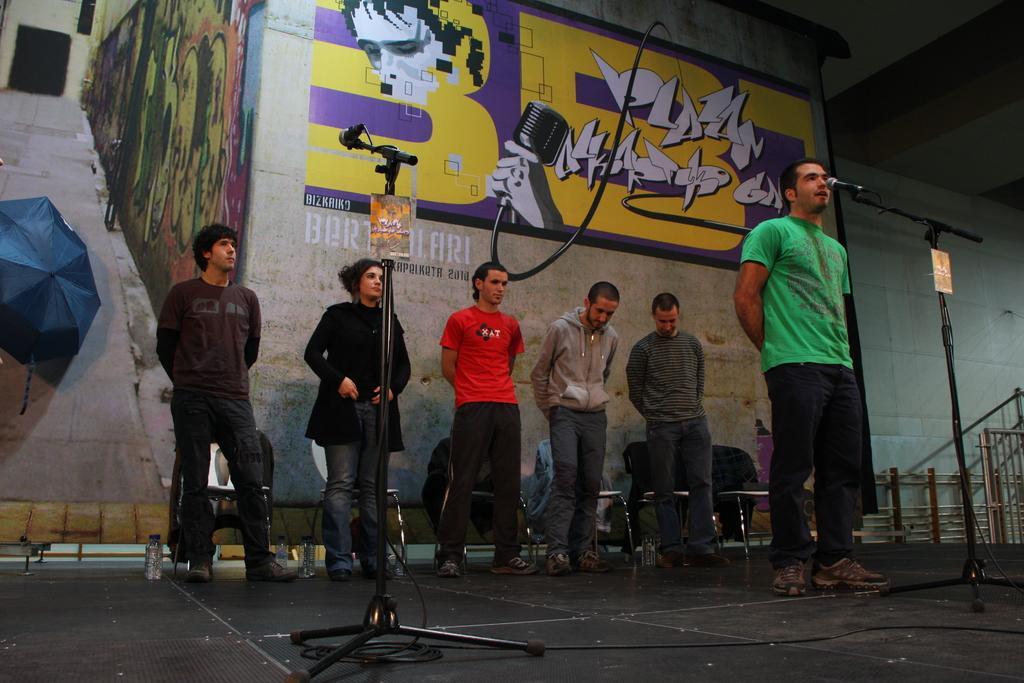Can you describe this image briefly? In the center of the image we can see many persons performing on dais. On the right side of the image we can see person standing at the mic. In the background we can see wall, painting and chairs. 